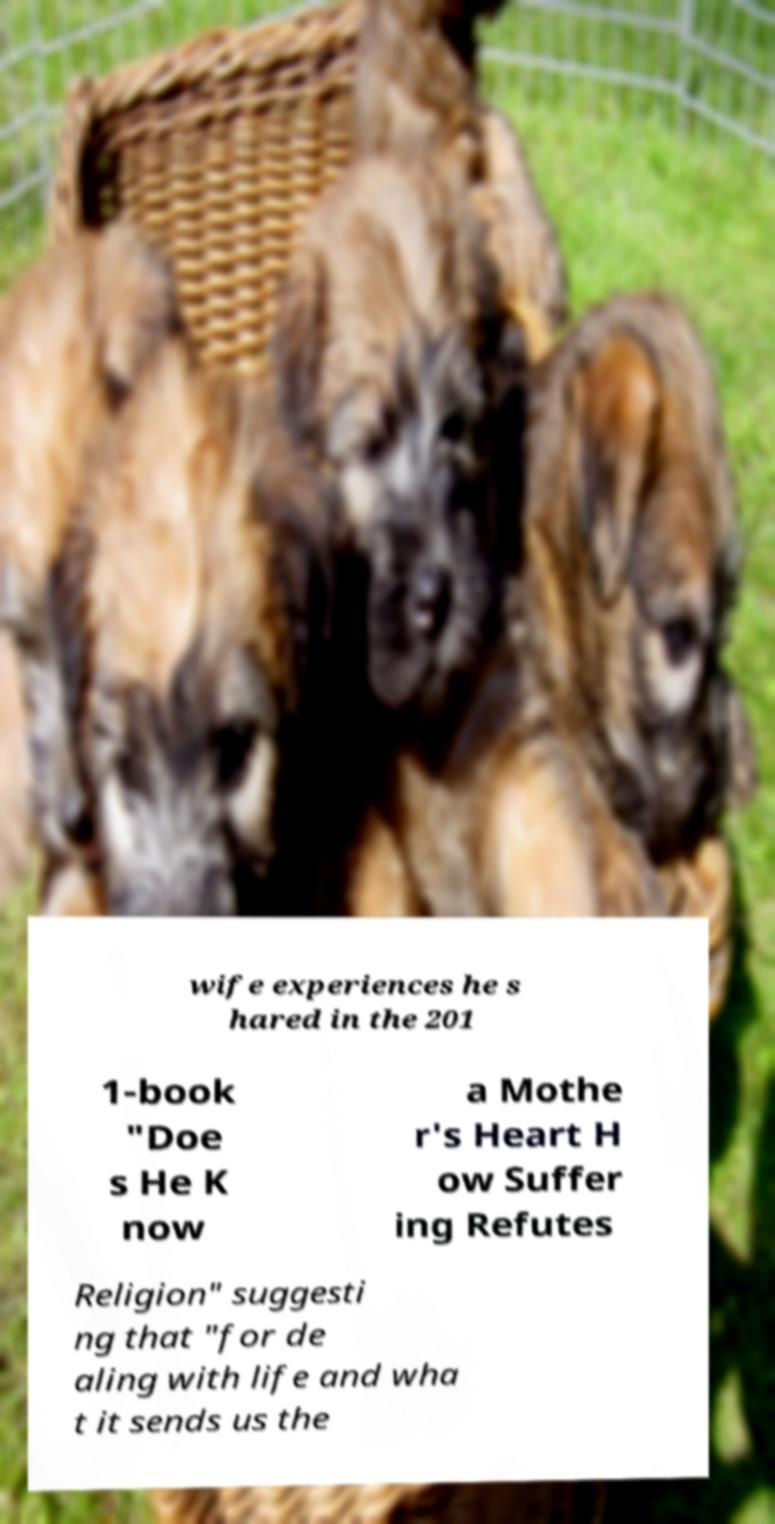Could you assist in decoding the text presented in this image and type it out clearly? wife experiences he s hared in the 201 1-book "Doe s He K now a Mothe r's Heart H ow Suffer ing Refutes Religion" suggesti ng that "for de aling with life and wha t it sends us the 